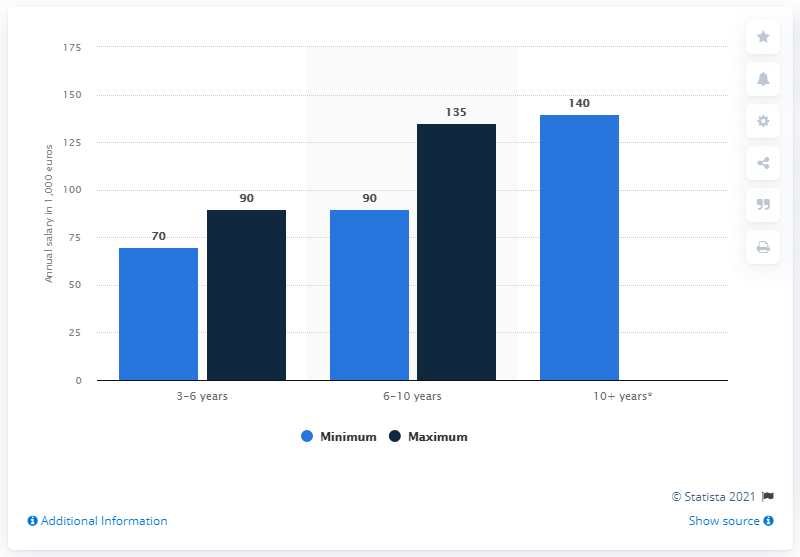Point out several critical features in this image. The difference between the shortest light blue bar and the tallest dark blue bar is -65. The difference between the highest and lowest dark blue bar is 45. 